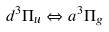<formula> <loc_0><loc_0><loc_500><loc_500>d ^ { 3 } \Pi _ { u } \Leftrightarrow a ^ { 3 } \Pi _ { g }</formula> 